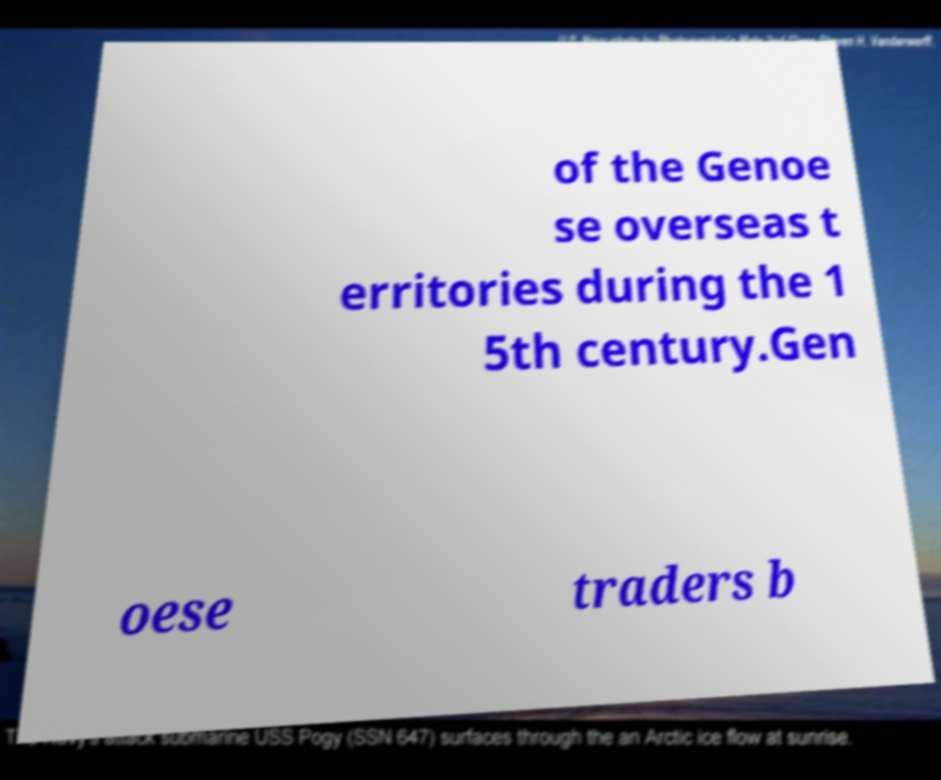What messages or text are displayed in this image? I need them in a readable, typed format. of the Genoe se overseas t erritories during the 1 5th century.Gen oese traders b 